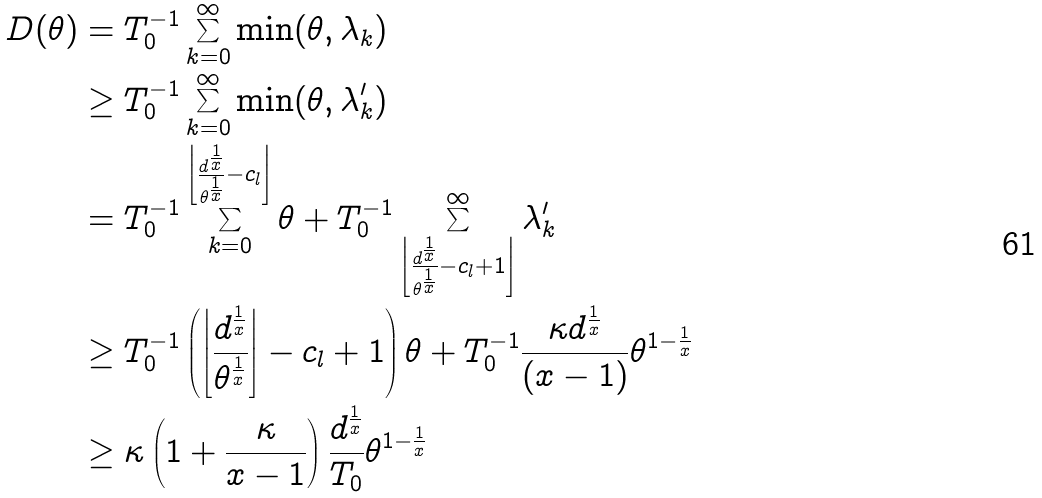Convert formula to latex. <formula><loc_0><loc_0><loc_500><loc_500>D ( \theta ) & = T _ { 0 } ^ { - 1 } \sum _ { k = 0 } ^ { \infty } \min ( \theta , \lambda _ { k } ) \\ & \geq T _ { 0 } ^ { - 1 } \sum _ { k = 0 } ^ { \infty } \min ( \theta , \lambda _ { k } ^ { \prime } ) \\ & = T _ { 0 } ^ { - 1 } \sum _ { k = 0 } ^ { \left \lfloor \frac { d ^ { \frac { 1 } { x } } } { \theta ^ { \frac { 1 } { x } } } - c _ { l } \right \rfloor } \theta + T _ { 0 } ^ { - 1 } \sum _ { \left \lfloor \frac { d ^ { \frac { 1 } { x } } } { \theta ^ { \frac { 1 } { x } } } - c _ { l } + 1 \right \rfloor } ^ { \infty } \lambda _ { k } ^ { \prime } \\ & \geq T _ { 0 } ^ { - 1 } \left ( \left \lfloor \frac { d ^ { \frac { 1 } { x } } } { \theta ^ { \frac { 1 } { x } } } \right \rfloor - c _ { l } + 1 \right ) \theta + T _ { 0 } ^ { - 1 } \frac { \kappa d ^ { \frac { 1 } { x } } } { ( x - 1 ) } \theta ^ { 1 - \frac { 1 } { x } } \\ & \geq \kappa \left ( 1 + \frac { \kappa } { x - 1 } \right ) \frac { d ^ { \frac { 1 } { x } } } { T _ { 0 } } \theta ^ { 1 - \frac { 1 } { x } }</formula> 